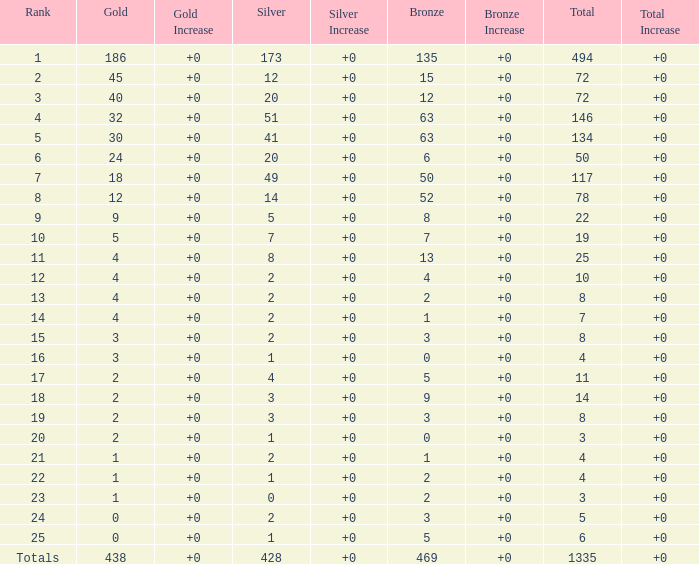What is the total amount of gold medals when there were more than 20 silvers and there were 135 bronze medals? 1.0. 